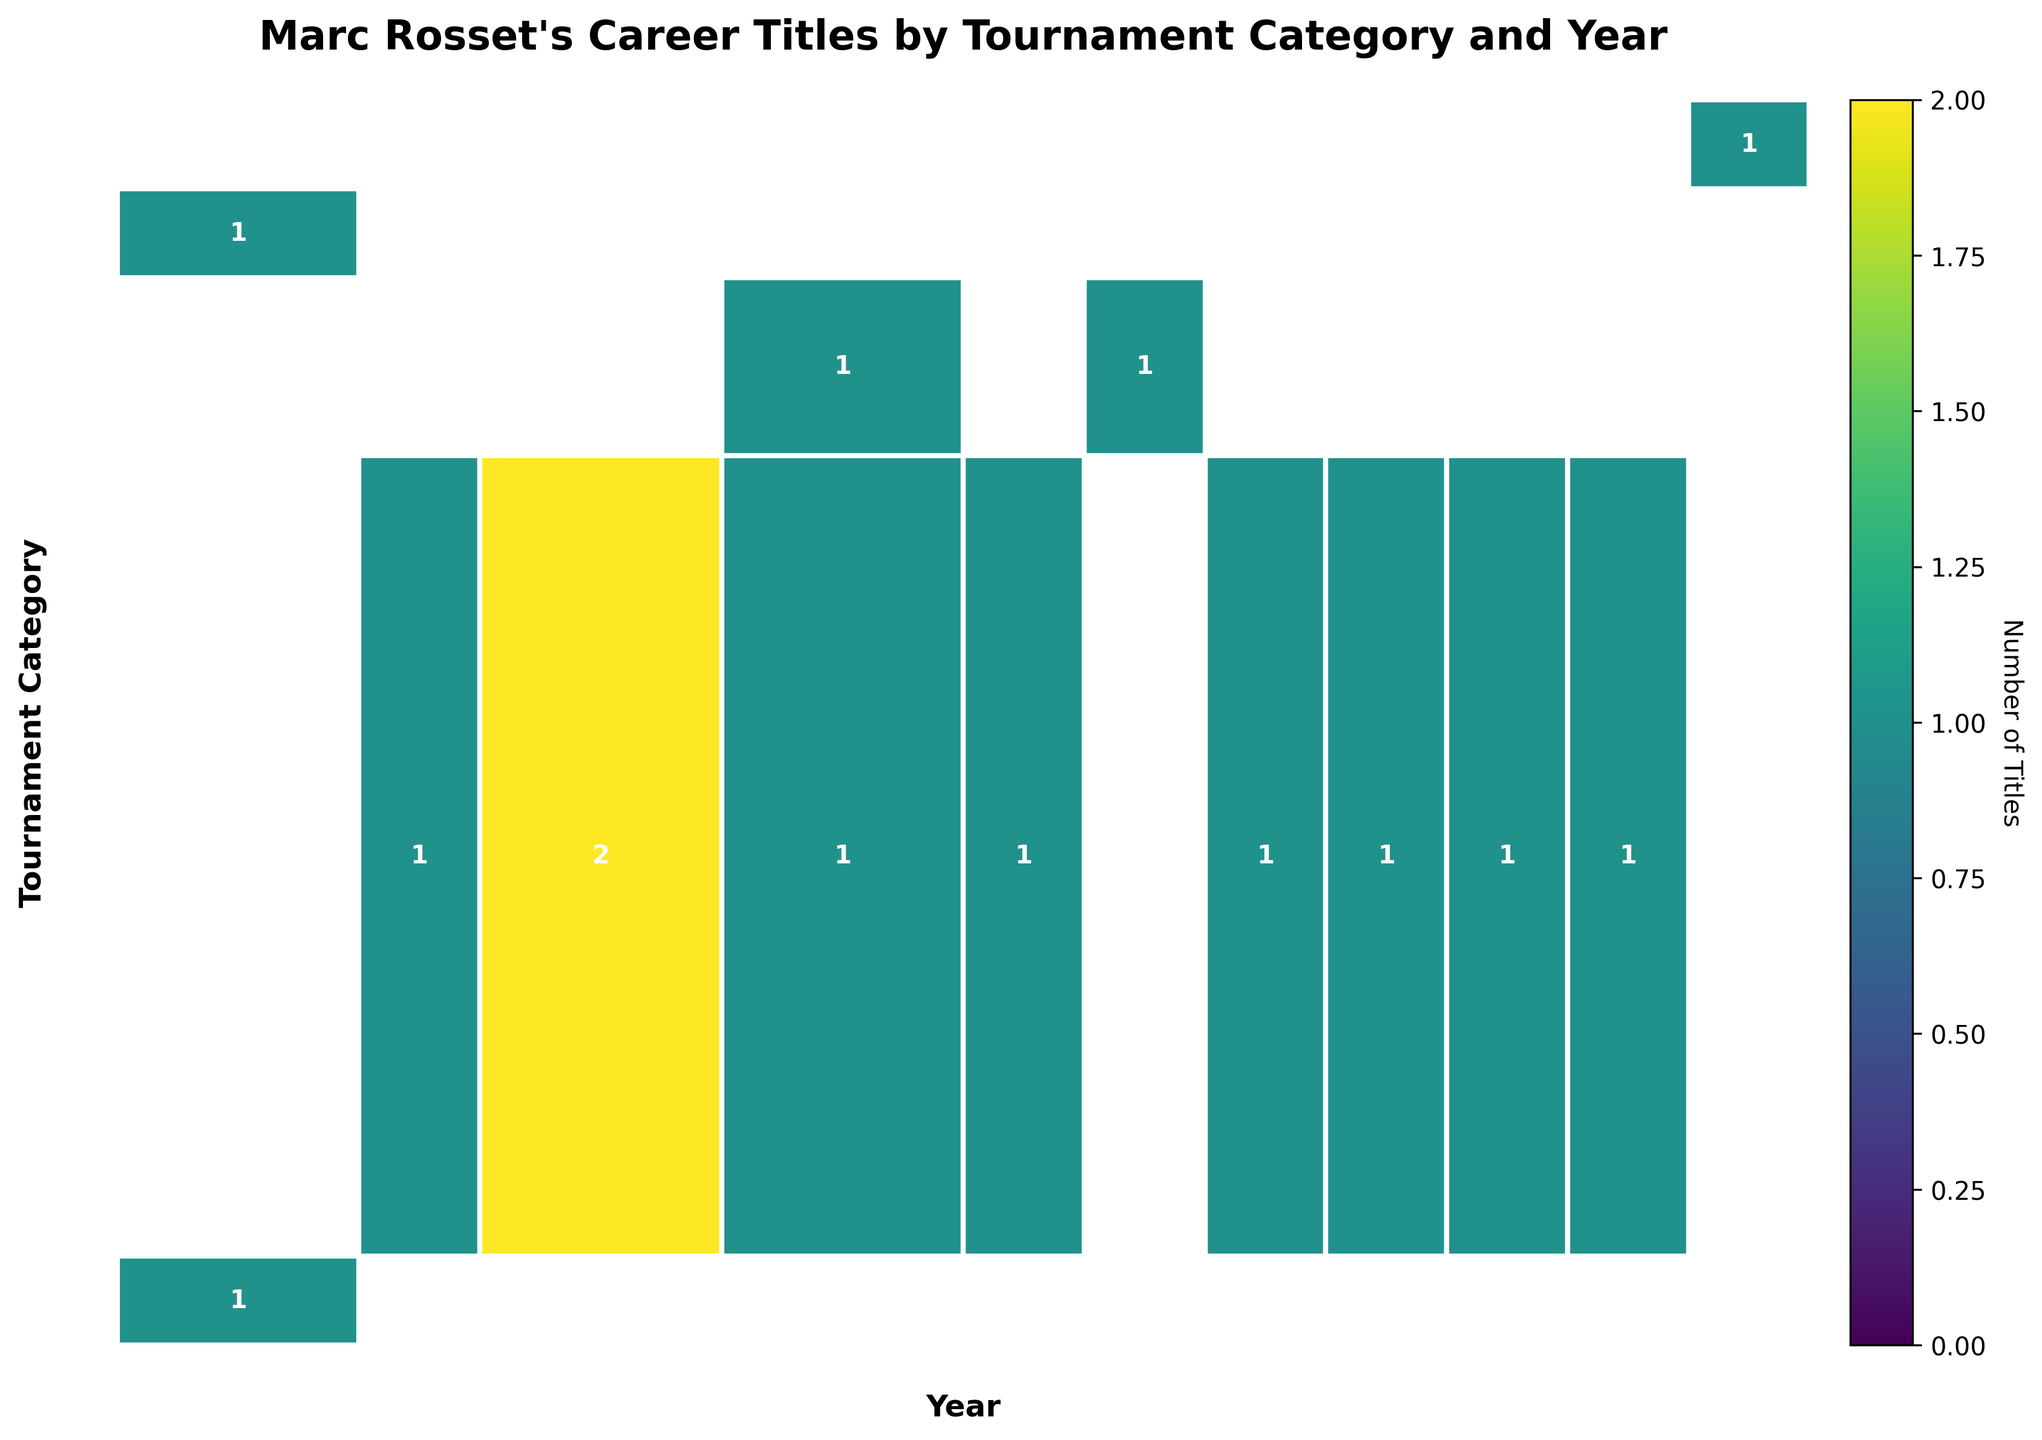number of titles in each category in 1992? Look at the 1992 column and identify the values for each tournament category in that year. The categories "Grand Slam" and "Olympic Games" each have 1 title in 1992.
Answer: 2 Which year's data has the highest number of Grand Slam titles? Identify the years within the "Grand Slam" category and their respective titles. Only 1992 has titles, with 1 Grand Slam title.
Answer: 1992 How many ATP Tour 250 titles did Marc Rosset win between 1990 and 2000? Sum the titles in the "ATP Tour 250" category from 1990 to 2000: 1 (1990) + 2 (1991) + 1 (1993) + 1 (1994) + 1 (1997) + 1 (1998) + 1 (1999) + 1 (2000) = 9.
Answer: 9 Hold the highest title count in any single year? Compare the number entries for each year across all categories to find the maximum. 1991 has the highest entry with 2 titles in the ATP Tour 250 category.
Answer: 1991 Which tournament category has the most diverse distribution of titles across the years? Count the number of different years titles were won in each category. "ATP Tour 250" has titles in eight different years, whereas other categories have fewer years with titles.
Answer: ATP Tour 250 Did Marc Rosset win more "ATP Tour 500" or "ATP Tour Masters 1000" titles throughout his career? Compare sums: "ATP Tour 500" has titles in 1993 and 1995 (1 each), total of 2. "ATP Tour Masters 1000" has 1 title in 1989. 2 > 1.
Answer: ATP Tour 500 What is the total number of titles Marc Rosset won in 1992? Sum the titles for all categories in the year 1992: "Grand Slam" (1) + "Olympic Games" (1) = 2.
Answer: 2 The total number of titles won in ATP Tour 500 and Grand Slam combined? Sum the titles for both categories across the years: "ATP Tour 500" = 2 (1993,1995) and "Grand Slam" = 1 (1992). 2 + 1 = 3.
Answer: 3 